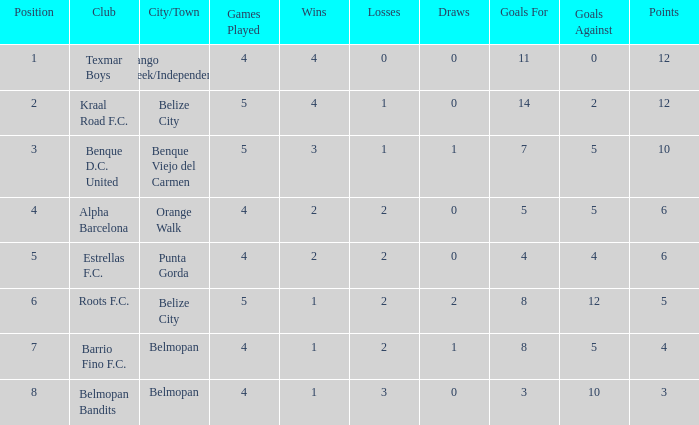What is the minimum games played with goals for/against being 7-5 5.0. 